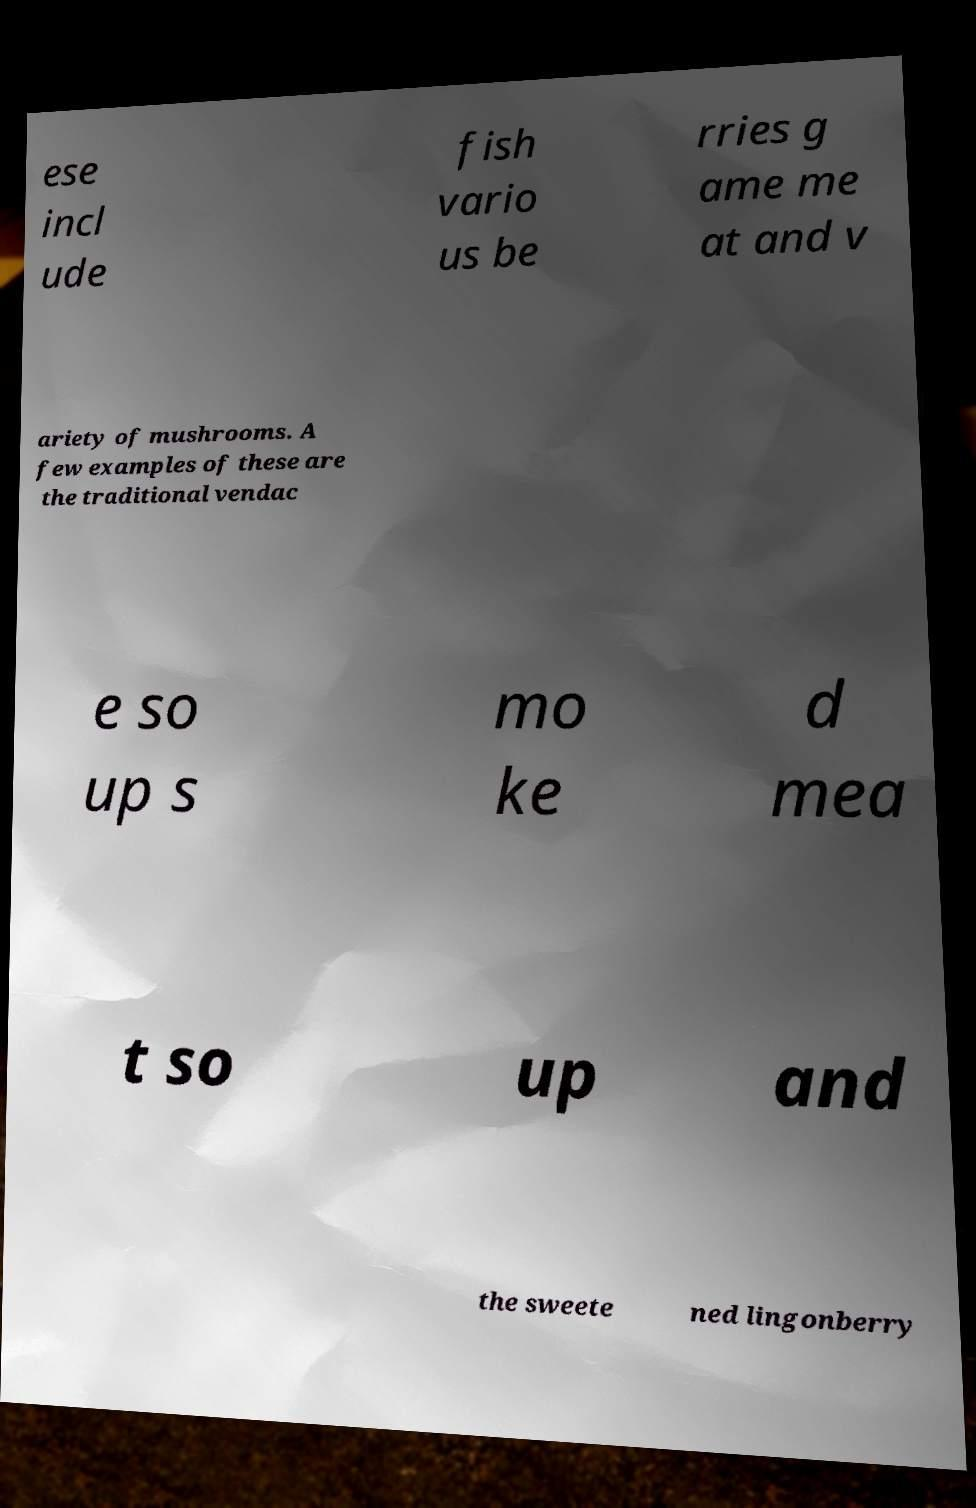Could you assist in decoding the text presented in this image and type it out clearly? ese incl ude fish vario us be rries g ame me at and v ariety of mushrooms. A few examples of these are the traditional vendac e so up s mo ke d mea t so up and the sweete ned lingonberry 